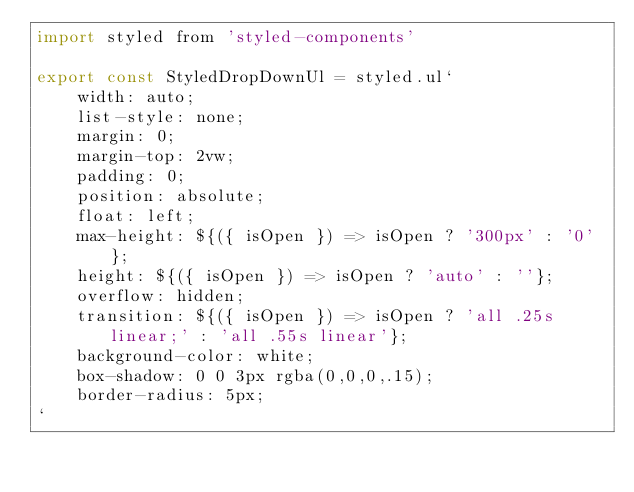<code> <loc_0><loc_0><loc_500><loc_500><_JavaScript_>import styled from 'styled-components'

export const StyledDropDownUl = styled.ul`
    width: auto;
    list-style: none;
    margin: 0;
    margin-top: 2vw;
    padding: 0;
    position: absolute;
    float: left;
    max-height: ${({ isOpen }) => isOpen ? '300px' : '0'};
    height: ${({ isOpen }) => isOpen ? 'auto' : ''};
    overflow: hidden;
    transition: ${({ isOpen }) => isOpen ? 'all .25s linear;' : 'all .55s linear'};
    background-color: white;
    box-shadow: 0 0 3px rgba(0,0,0,.15);
    border-radius: 5px;
`
</code> 